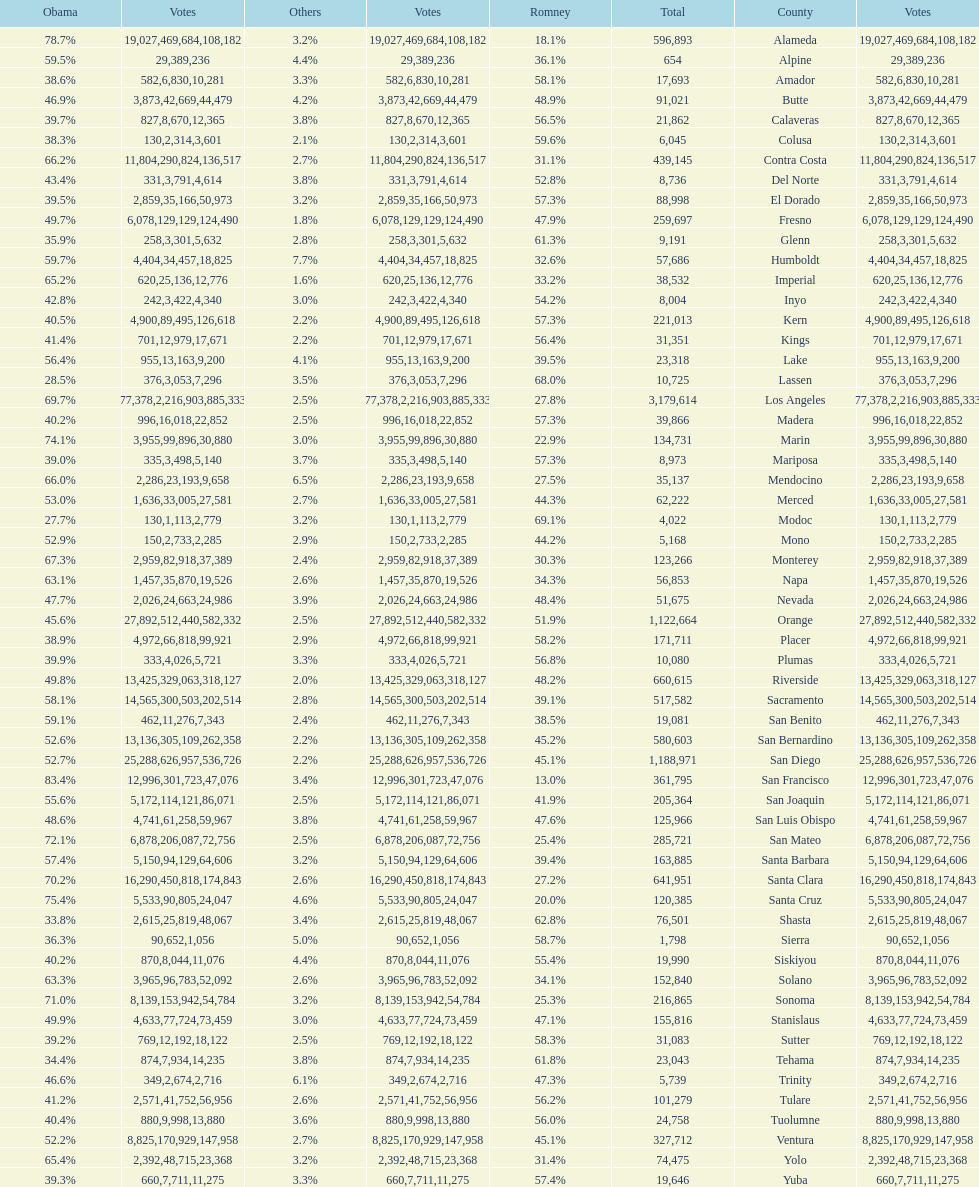How many counties had at least 75% of the votes for obama? 3. 